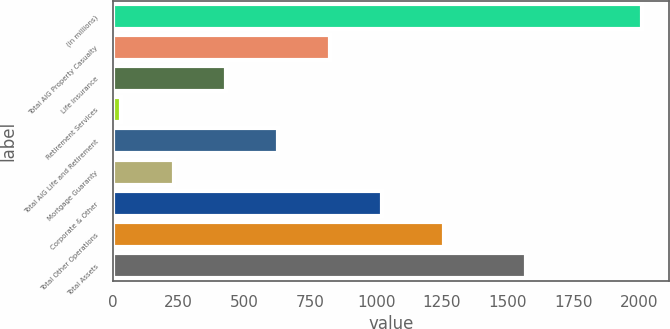<chart> <loc_0><loc_0><loc_500><loc_500><bar_chart><fcel>(in millions)<fcel>Total AIG Property Casualty<fcel>Life Insurance<fcel>Retirement Services<fcel>Total AIG Life and Retirement<fcel>Mortgage Guaranty<fcel>Corporate & Other<fcel>Total Other Operations<fcel>Total Assets<nl><fcel>2011<fcel>824.2<fcel>428.6<fcel>33<fcel>626.4<fcel>230.8<fcel>1022<fcel>1259<fcel>1568<nl></chart> 